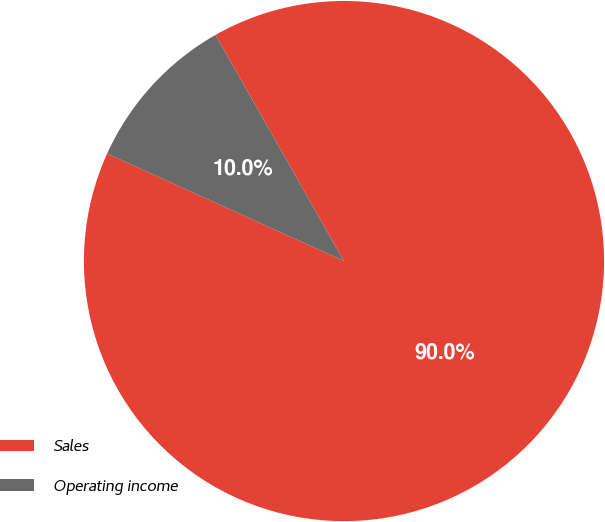Convert chart. <chart><loc_0><loc_0><loc_500><loc_500><pie_chart><fcel>Sales<fcel>Operating income<nl><fcel>90.0%<fcel>10.0%<nl></chart> 